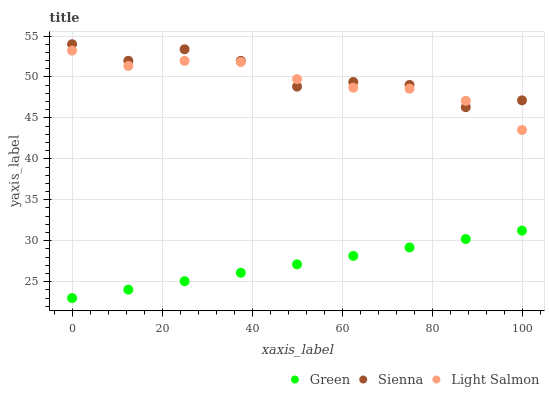Does Green have the minimum area under the curve?
Answer yes or no. Yes. Does Sienna have the maximum area under the curve?
Answer yes or no. Yes. Does Light Salmon have the minimum area under the curve?
Answer yes or no. No. Does Light Salmon have the maximum area under the curve?
Answer yes or no. No. Is Green the smoothest?
Answer yes or no. Yes. Is Sienna the roughest?
Answer yes or no. Yes. Is Light Salmon the smoothest?
Answer yes or no. No. Is Light Salmon the roughest?
Answer yes or no. No. Does Green have the lowest value?
Answer yes or no. Yes. Does Light Salmon have the lowest value?
Answer yes or no. No. Does Sienna have the highest value?
Answer yes or no. Yes. Does Light Salmon have the highest value?
Answer yes or no. No. Is Green less than Light Salmon?
Answer yes or no. Yes. Is Light Salmon greater than Green?
Answer yes or no. Yes. Does Light Salmon intersect Sienna?
Answer yes or no. Yes. Is Light Salmon less than Sienna?
Answer yes or no. No. Is Light Salmon greater than Sienna?
Answer yes or no. No. Does Green intersect Light Salmon?
Answer yes or no. No. 